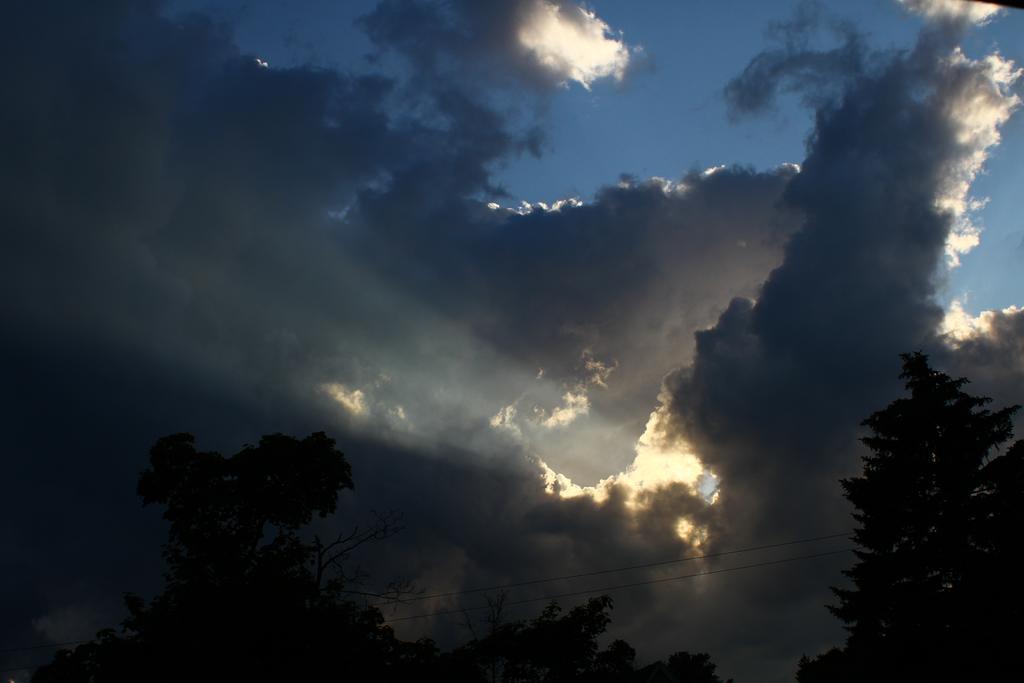Can you describe this image briefly? In this image we can see some trees and cloudy sky. 